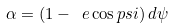<formula> <loc_0><loc_0><loc_500><loc_500>\alpha = \left ( 1 - \ e \cos p s i \right ) d \psi</formula> 